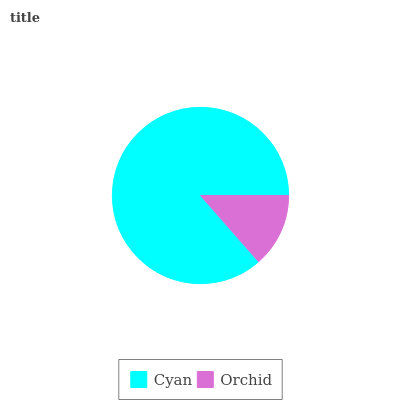Is Orchid the minimum?
Answer yes or no. Yes. Is Cyan the maximum?
Answer yes or no. Yes. Is Orchid the maximum?
Answer yes or no. No. Is Cyan greater than Orchid?
Answer yes or no. Yes. Is Orchid less than Cyan?
Answer yes or no. Yes. Is Orchid greater than Cyan?
Answer yes or no. No. Is Cyan less than Orchid?
Answer yes or no. No. Is Cyan the high median?
Answer yes or no. Yes. Is Orchid the low median?
Answer yes or no. Yes. Is Orchid the high median?
Answer yes or no. No. Is Cyan the low median?
Answer yes or no. No. 